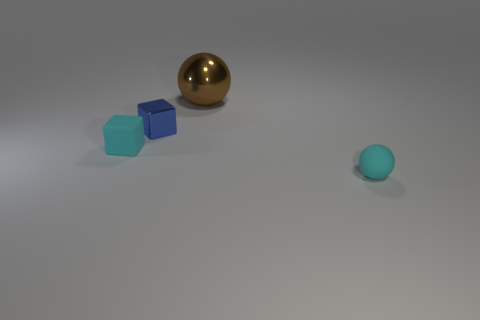What number of tiny brown shiny objects are there?
Ensure brevity in your answer.  0. Is the big thing made of the same material as the small cyan object that is behind the cyan ball?
Ensure brevity in your answer.  No. Do the object to the right of the brown metallic object and the big thing have the same color?
Offer a very short reply. No. There is a thing that is both behind the cyan rubber ball and on the right side of the small blue metallic object; what material is it?
Your answer should be compact. Metal. How big is the brown sphere?
Provide a succinct answer. Large. There is a small rubber ball; is its color the same as the object to the left of the blue shiny thing?
Give a very brief answer. Yes. How many other things are the same color as the rubber ball?
Keep it short and to the point. 1. Do the matte thing that is to the left of the cyan matte ball and the cyan rubber ball that is on the right side of the small blue shiny cube have the same size?
Keep it short and to the point. Yes. What is the color of the sphere that is left of the small rubber ball?
Your answer should be very brief. Brown. Are there fewer tiny blue cubes right of the small rubber ball than large brown rubber blocks?
Give a very brief answer. No. 